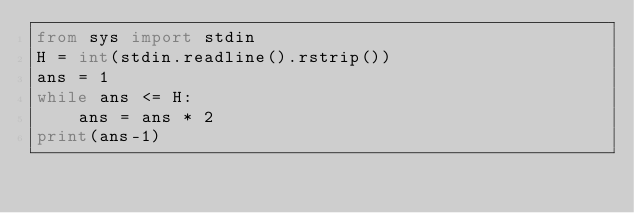<code> <loc_0><loc_0><loc_500><loc_500><_Python_>from sys import stdin
H = int(stdin.readline().rstrip())
ans = 1
while ans <= H:
    ans = ans * 2
print(ans-1)</code> 